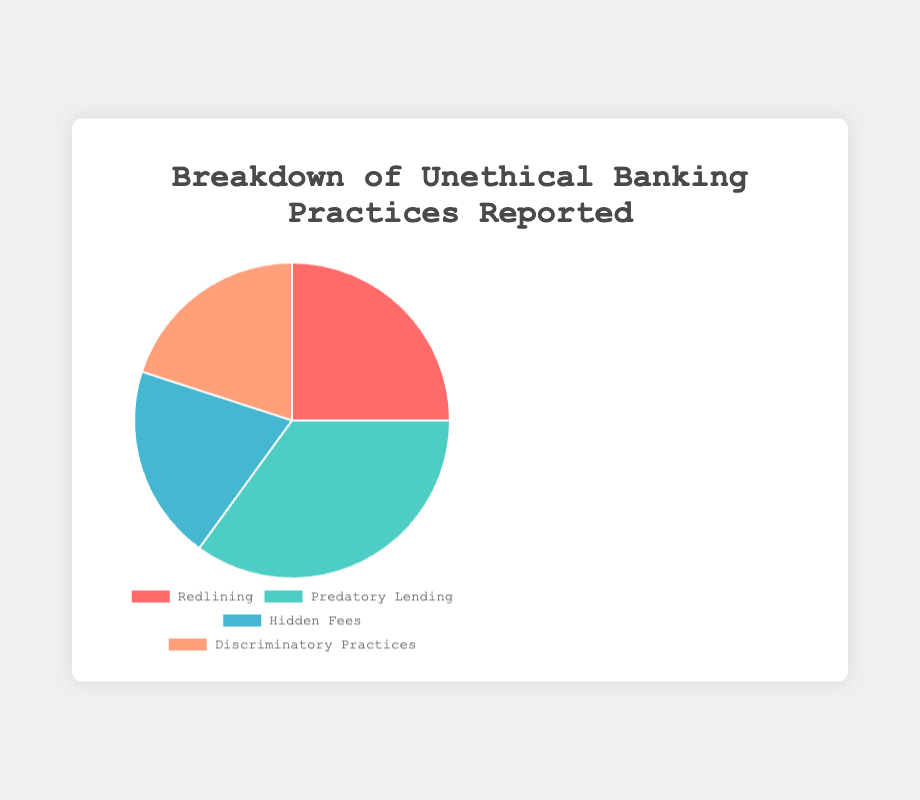What is the most frequently reported unethical banking practice? According to the pie chart, Predatory Lending is the segment with the highest percentage, which is 35%.
Answer: Predatory Lending What is the total percentage of reports for Hidden Fees and Discriminatory Practices combined? According to the pie chart, both Hidden Fees and Discriminatory Practices have a 20% share each. Therefore, their combined total is 20% + 20% = 40%.
Answer: 40% Which practice has a higher report percentage, Redlining or Hidden Fees? According to the pie chart, Redlining has a 25% share whereas Hidden Fees has a 20% share. 25% is greater than 20%.
Answer: Redlining What is the combined percentage of reports for Predatory Lending and Redlining? The pie chart shows that Predatory Lending has a 35% share and Redlining has a 25% share. Their combined total is 35% + 25% = 60%.
Answer: 60% What is the difference in reported percentages between the highest and lowest unethical practices? The highest reported practice is Predatory Lending at 35%, and the lowest reported practices (tied) are Hidden Fees and Discriminatory Practices at 20% each. The difference is 35% - 20% = 15%.
Answer: 15% Which color segment in the pie chart represents Redlining? The pie chart uses the color red for the Redlining segment.
Answer: Red What is the average percentage of all reported unethical banking practices? There are four reported practices with percentages of 25%, 35%, 20%, and 20%. Summing these gives 100%. The average is calculated as 100% / 4 = 25%.
Answer: 25% How do the percentages of Hidden Fees and Discriminatory Practices compare? According to the pie chart, both Hidden Fees and Discriminatory Practices are reported at 20% each, meaning they have equal percentages.
Answer: Equal What visual element of the chart makes it easy to identify the most and least reported practices? The pie chart uses different colored segments for each practice, with the size of each segment representing the percentage value. Larger segments indicate higher percentages, making it easy to identify the most and least reported practices.
Answer: Segment size and color What’s the percentage difference between Redlining and the average percentage of all practices? The average percentage of all reported practices is 25%. Redlining also has 25%, so the percentage difference is 25% - 25% = 0%.
Answer: 0% 